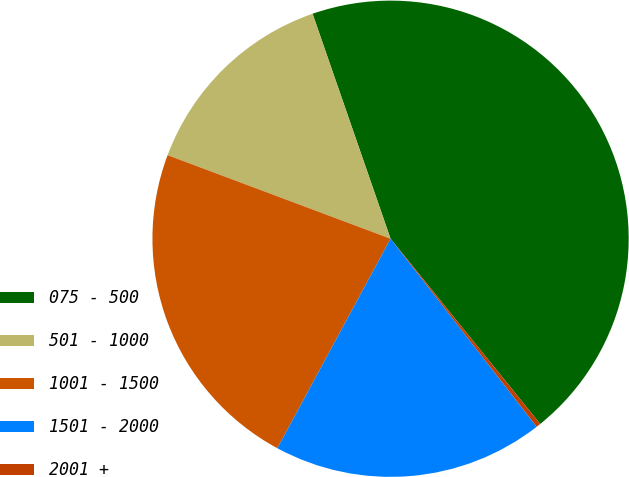Convert chart. <chart><loc_0><loc_0><loc_500><loc_500><pie_chart><fcel>075 - 500<fcel>501 - 1000<fcel>1001 - 1500<fcel>1501 - 2000<fcel>2001 +<nl><fcel>44.49%<fcel>13.98%<fcel>22.82%<fcel>18.4%<fcel>0.3%<nl></chart> 